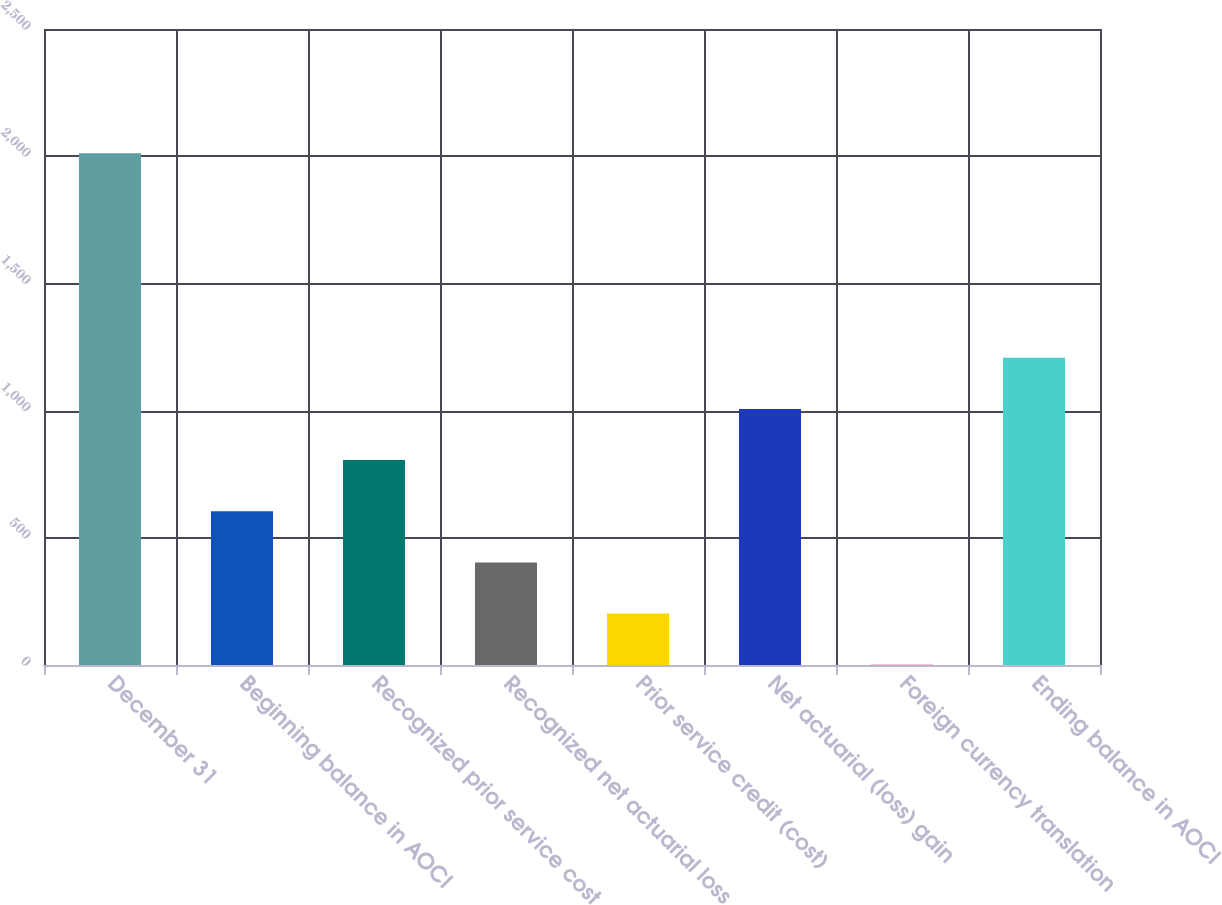<chart> <loc_0><loc_0><loc_500><loc_500><bar_chart><fcel>December 31<fcel>Beginning balance in AOCI<fcel>Recognized prior service cost<fcel>Recognized net actuarial loss<fcel>Prior service credit (cost)<fcel>Net actuarial (loss) gain<fcel>Foreign currency translation<fcel>Ending balance in AOCI<nl><fcel>2012<fcel>604.3<fcel>805.4<fcel>403.2<fcel>202.1<fcel>1006.5<fcel>1<fcel>1207.6<nl></chart> 